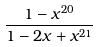<formula> <loc_0><loc_0><loc_500><loc_500>\frac { 1 - x ^ { 2 0 } } { 1 - 2 x + x ^ { 2 1 } }</formula> 